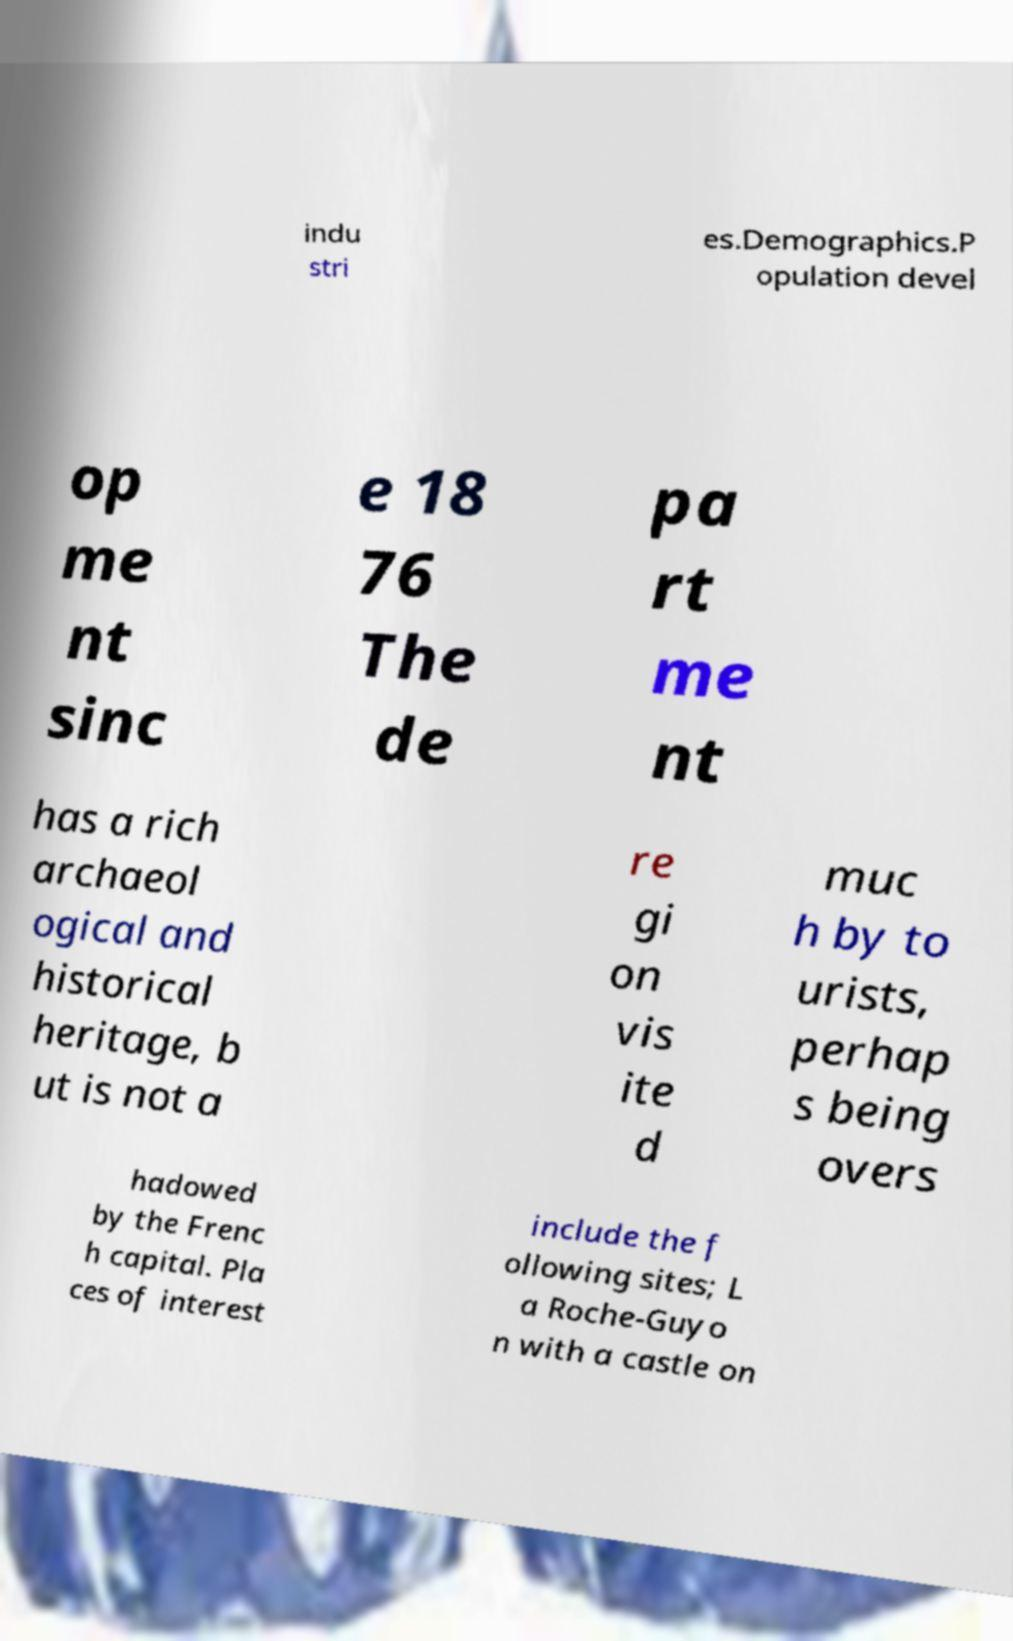Could you extract and type out the text from this image? indu stri es.Demographics.P opulation devel op me nt sinc e 18 76 The de pa rt me nt has a rich archaeol ogical and historical heritage, b ut is not a re gi on vis ite d muc h by to urists, perhap s being overs hadowed by the Frenc h capital. Pla ces of interest include the f ollowing sites; L a Roche-Guyo n with a castle on 